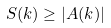Convert formula to latex. <formula><loc_0><loc_0><loc_500><loc_500>S ( { k } ) \geq | A ( { k } ) |</formula> 